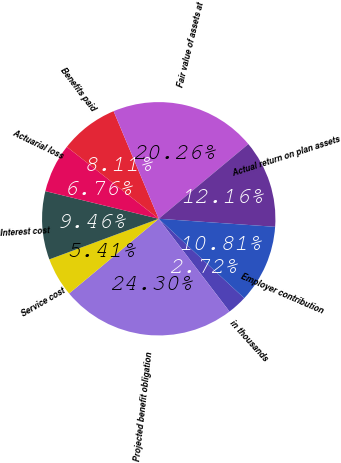Convert chart. <chart><loc_0><loc_0><loc_500><loc_500><pie_chart><fcel>in thousands<fcel>Projected benefit obligation<fcel>Service cost<fcel>Interest cost<fcel>Actuarial loss<fcel>Benefits paid<fcel>Fair value of assets at<fcel>Actual return on plan assets<fcel>Employer contribution<nl><fcel>2.72%<fcel>24.3%<fcel>5.41%<fcel>9.46%<fcel>6.76%<fcel>8.11%<fcel>20.26%<fcel>12.16%<fcel>10.81%<nl></chart> 